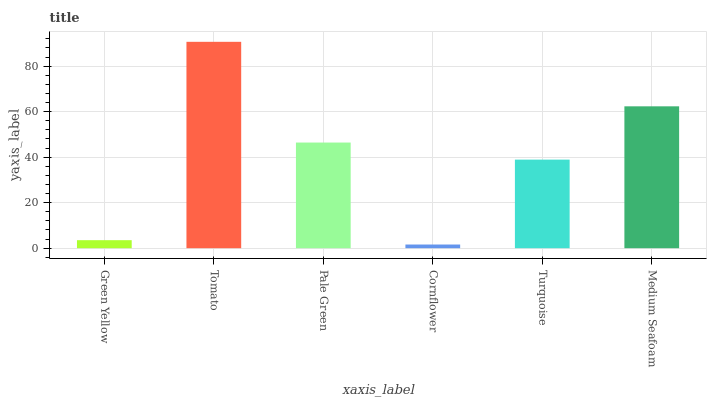Is Pale Green the minimum?
Answer yes or no. No. Is Pale Green the maximum?
Answer yes or no. No. Is Tomato greater than Pale Green?
Answer yes or no. Yes. Is Pale Green less than Tomato?
Answer yes or no. Yes. Is Pale Green greater than Tomato?
Answer yes or no. No. Is Tomato less than Pale Green?
Answer yes or no. No. Is Pale Green the high median?
Answer yes or no. Yes. Is Turquoise the low median?
Answer yes or no. Yes. Is Medium Seafoam the high median?
Answer yes or no. No. Is Tomato the low median?
Answer yes or no. No. 